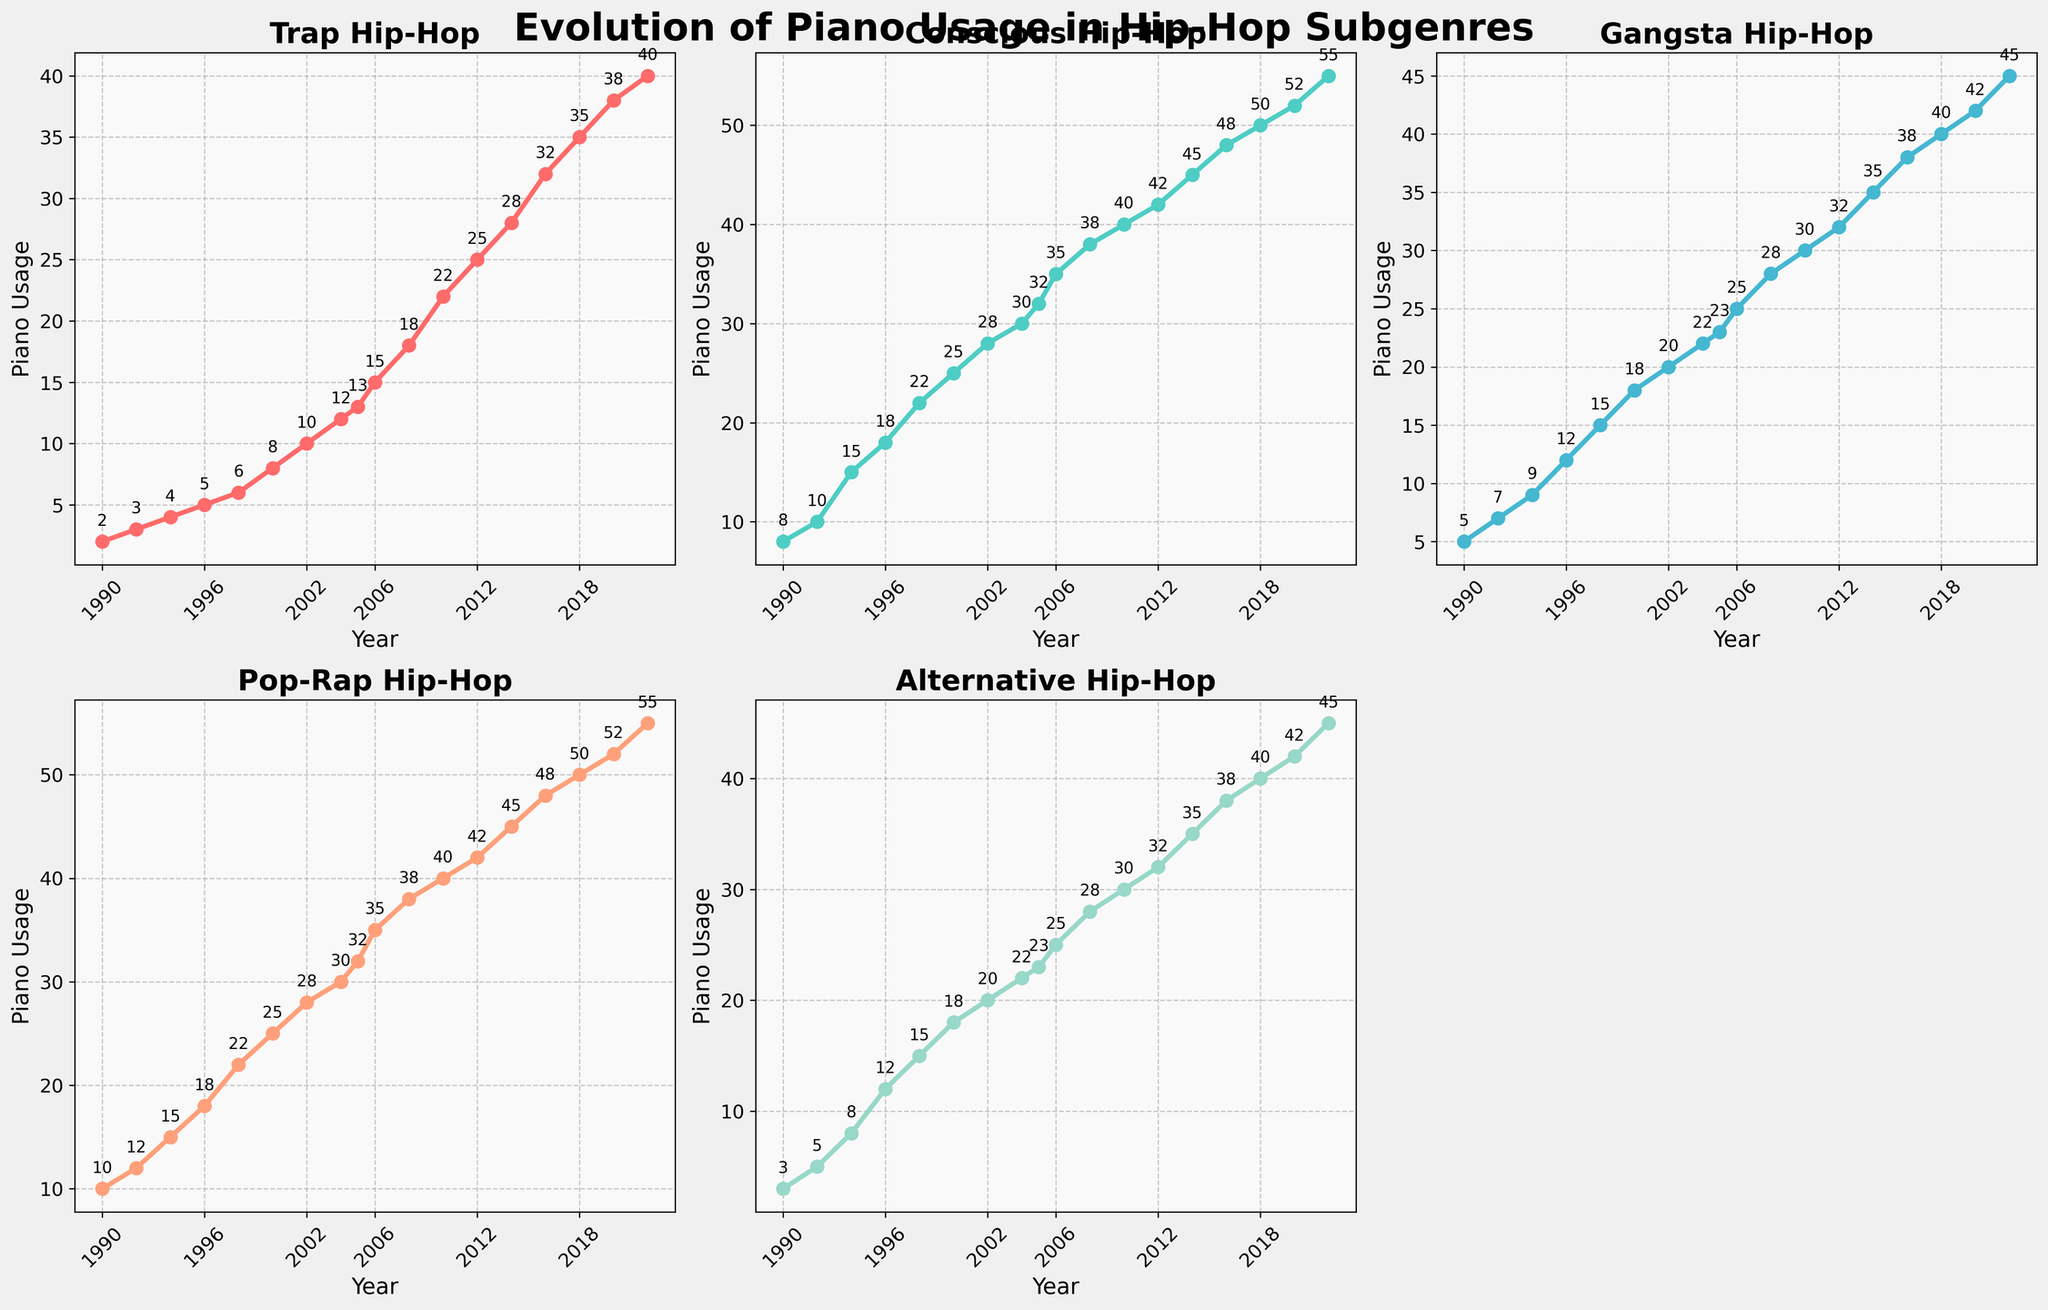What subgenre showed the highest increase in piano usage between 1990 and 2022? To answer this, look at the highest difference in values from the subplots between 1990 and 2022. Conscious Hip-Hop increased from 8 to 55, a difference of 47
Answer: Conscious Which year did Pop-Rap Hip-Hop reach its highest piano usage, and what was the value? Check the Pop-Rap subplot and identify the peak value and the corresponding year. The peak is at 55 in 2022
Answer: 2022, 55 Compare the piano usage in Trap Hip-Hop and Alternative Hip-Hop in 2010. Which one used more piano? Refer to the years 2010 on both subplots and compare the values. Trap Hip-Hop had 22, and Alternative had 30
Answer: Alternative What was the average piano usage across all subgenres in 2004? Add the 2004 values for the five subgenres (Trap: 12, Conscious: 30, Gangsta: 22, Pop-Rap: 30, Alternative: 22) and divide by 5. (12+30+22+30+22)/5 = 116/5 = 23.2
Answer: 23.2 In which year did Gangsta Hip-Hop surpass 40 piano usages, and what was the exact value? Look at the Gangsta subplot, find the first year exceeding 40; it happens in 2018 with a value of 40
Answer: 2018, 40 Which subgenre demonstrated the least fluctuation in piano usage over the years? Observe the subplots and identify the one with the least variance. Trap Hip-Hop shows steady incremental growth with minimal fluctuations
Answer: Trap Between 2000 and 2005, which subgenre saw the most significant increase in piano usage? Compare values from 2000 to 2005 on each subplot. Conscious Hip-Hop increased from 25 to 32, the highest among subgenres
Answer: Conscious Was there any year where the piano usage within a subgenre remained unchanged from the previous year? If so, specify the subgenre and year. Check for flat lines on each subplot. There are no flat lines; values change every year
Answer: No 